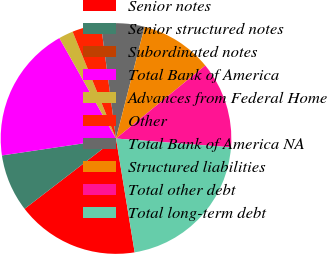<chart> <loc_0><loc_0><loc_500><loc_500><pie_chart><fcel>Senior notes<fcel>Senior structured notes<fcel>Subordinated notes<fcel>Total Bank of America<fcel>Advances from Federal Home<fcel>Other<fcel>Total Bank of America NA<fcel>Structured liabilities<fcel>Total other debt<fcel>Total long-term debt<nl><fcel>17.15%<fcel>8.09%<fcel>0.0%<fcel>19.17%<fcel>2.03%<fcel>4.05%<fcel>6.07%<fcel>10.11%<fcel>12.13%<fcel>21.19%<nl></chart> 